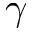<formula> <loc_0><loc_0><loc_500><loc_500>\gamma</formula> 